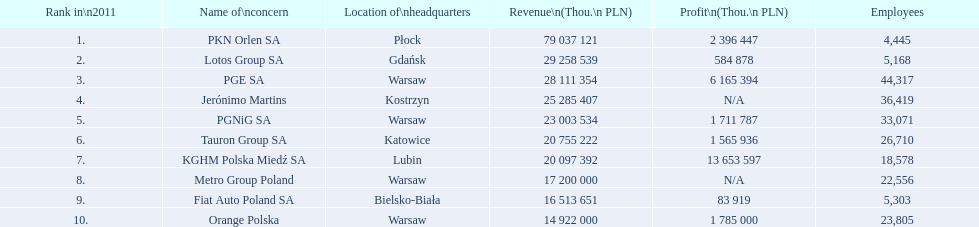What are the titles of all the concerns? PKN Orlen SA, Lotos Group SA, PGE SA, Jerónimo Martins, PGNiG SA, Tauron Group SA, KGHM Polska Miedź SA, Metro Group Poland, Fiat Auto Poland SA, Orange Polska. How many staff members are employed by pgnig sa? 33,071. 